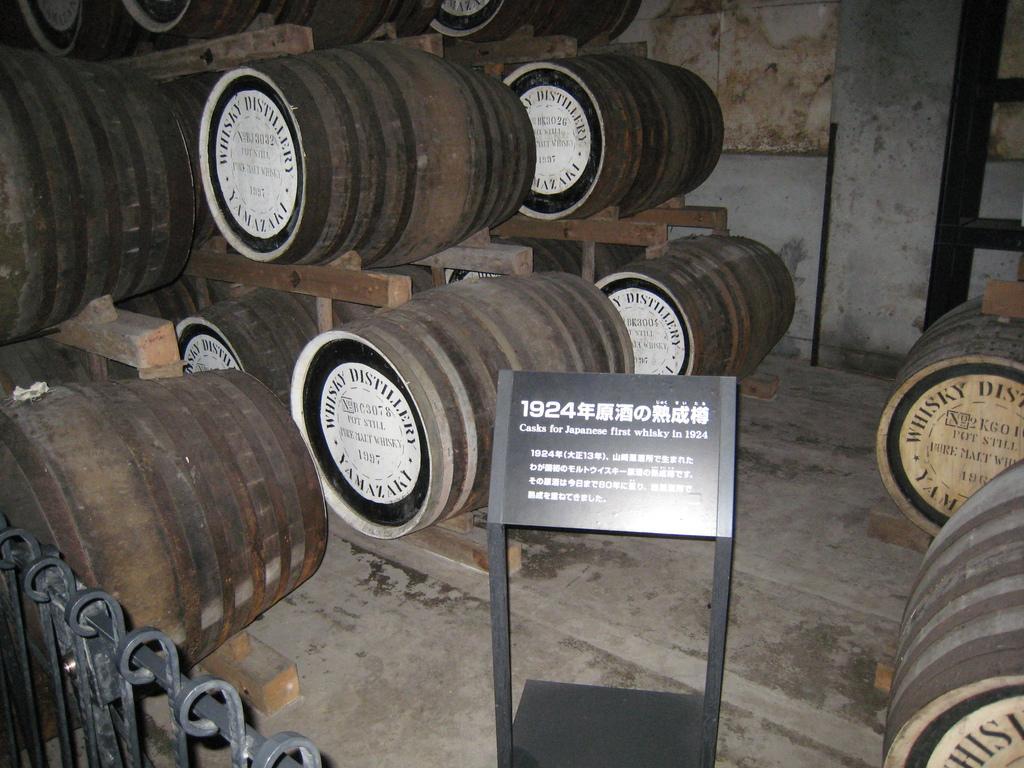Please provide a concise description of this image. In this image we can see wooden barrels, fence and stand board with some text. 